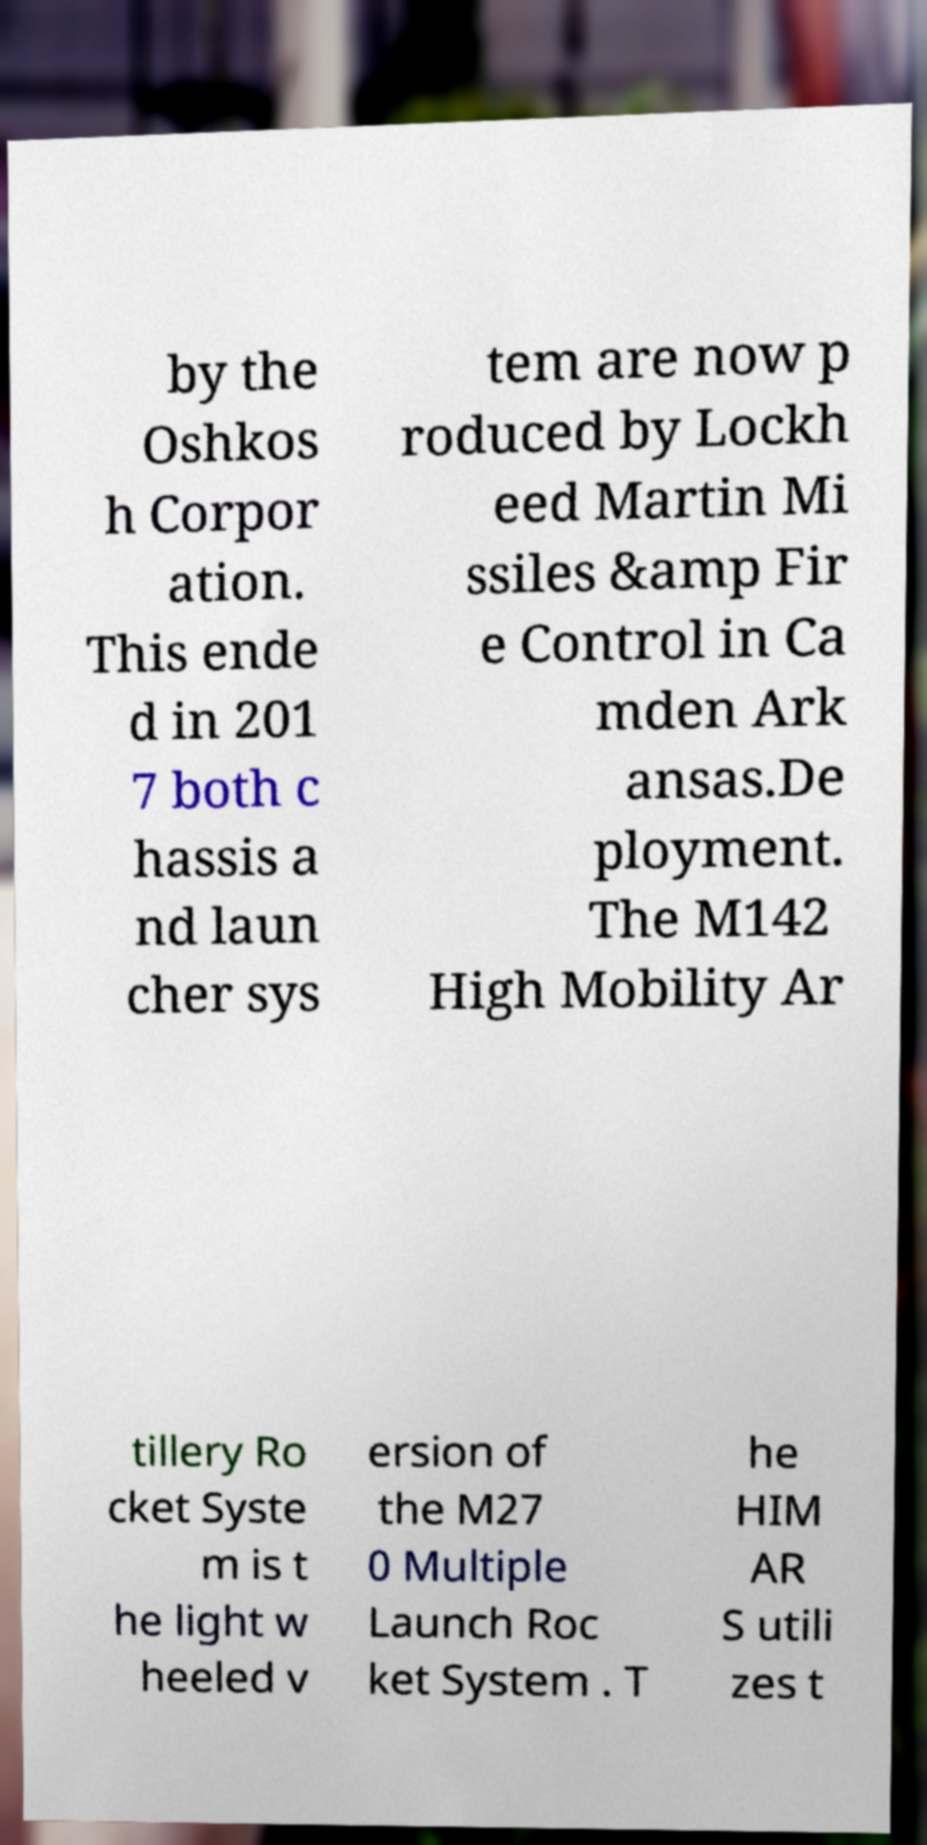Can you read and provide the text displayed in the image?This photo seems to have some interesting text. Can you extract and type it out for me? by the Oshkos h Corpor ation. This ende d in 201 7 both c hassis a nd laun cher sys tem are now p roduced by Lockh eed Martin Mi ssiles &amp Fir e Control in Ca mden Ark ansas.De ployment. The M142 High Mobility Ar tillery Ro cket Syste m is t he light w heeled v ersion of the M27 0 Multiple Launch Roc ket System . T he HIM AR S utili zes t 